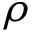<formula> <loc_0><loc_0><loc_500><loc_500>\rho</formula> 